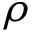<formula> <loc_0><loc_0><loc_500><loc_500>\rho</formula> 